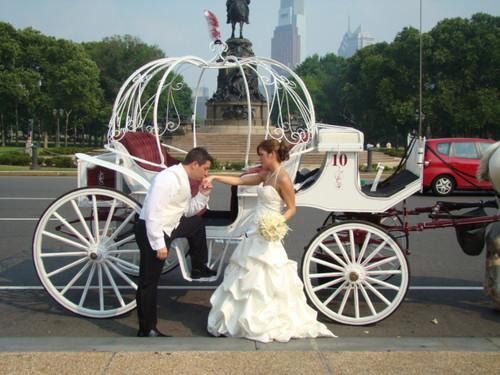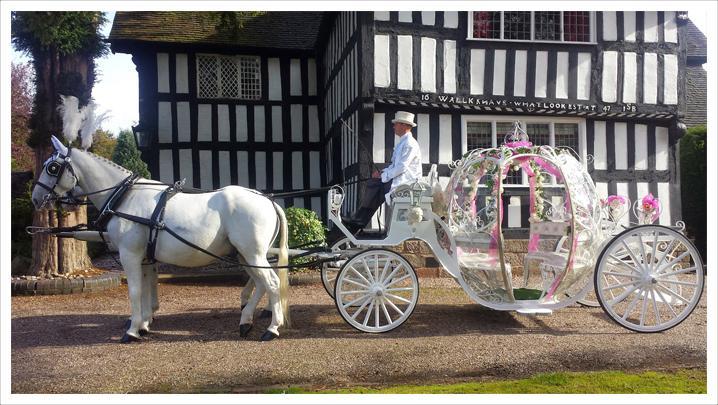The first image is the image on the left, the second image is the image on the right. For the images displayed, is the sentence "The only person in one image of a coach with a rounded top is the driver in his seat." factually correct? Answer yes or no. Yes. 